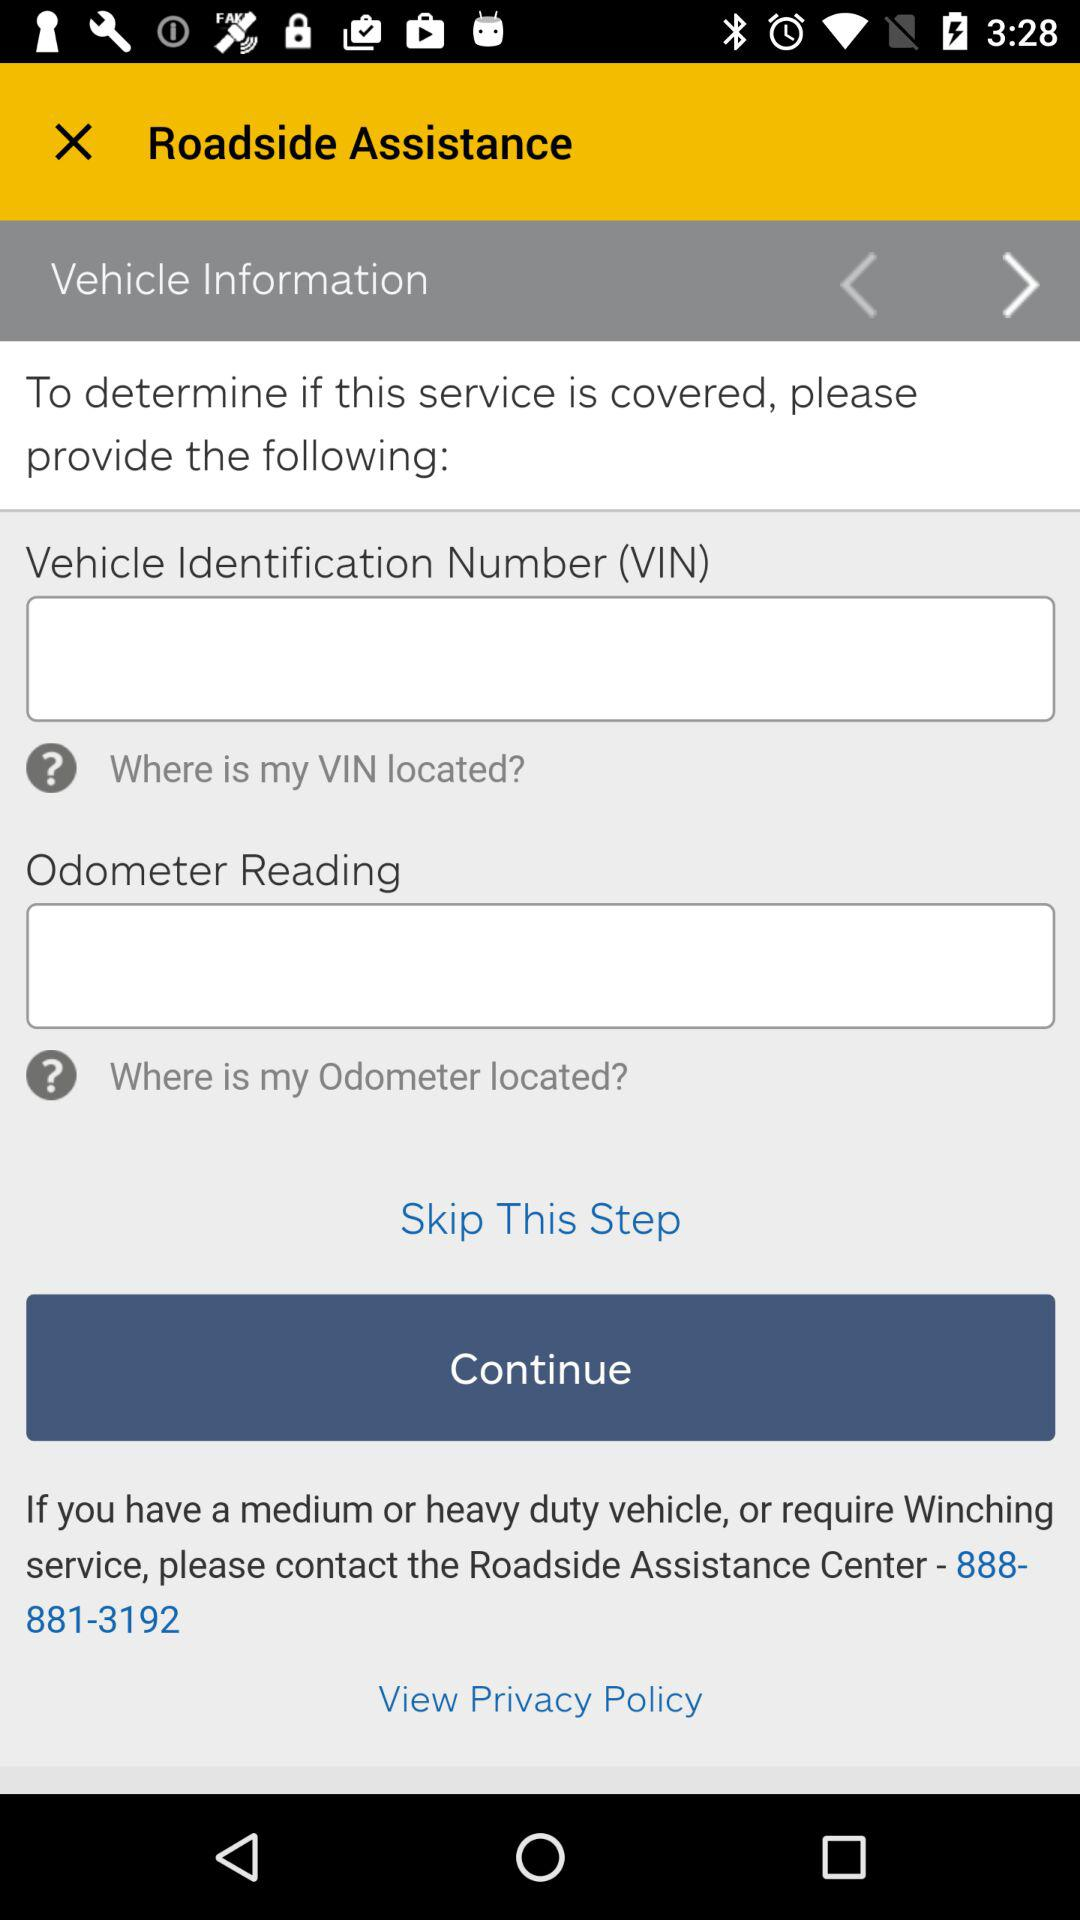How many text inputs have a question mark next to them?
Answer the question using a single word or phrase. 2 